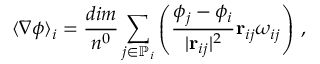Convert formula to latex. <formula><loc_0><loc_0><loc_500><loc_500>\langle \nabla \phi \rangle _ { i } = \frac { d i m } { n ^ { 0 } } \sum _ { j \in \mathbb { P } _ { i } } \left ( \frac { \phi _ { j } - \phi _ { i } } { | r _ { i j } | ^ { 2 } } r _ { i j } \omega _ { i j } \right ) \, ,</formula> 